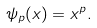<formula> <loc_0><loc_0><loc_500><loc_500>\psi _ { p } ( x ) = x ^ { p } .</formula> 